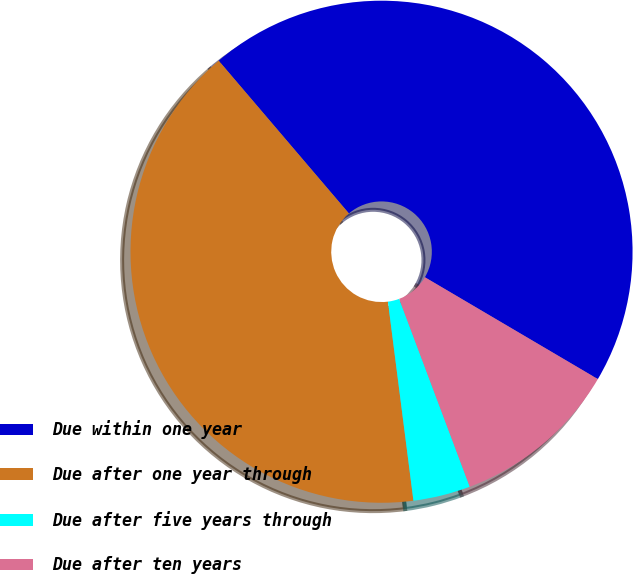Convert chart to OTSL. <chart><loc_0><loc_0><loc_500><loc_500><pie_chart><fcel>Due within one year<fcel>Due after one year through<fcel>Due after five years through<fcel>Due after ten years<nl><fcel>44.7%<fcel>40.79%<fcel>3.69%<fcel>10.81%<nl></chart> 